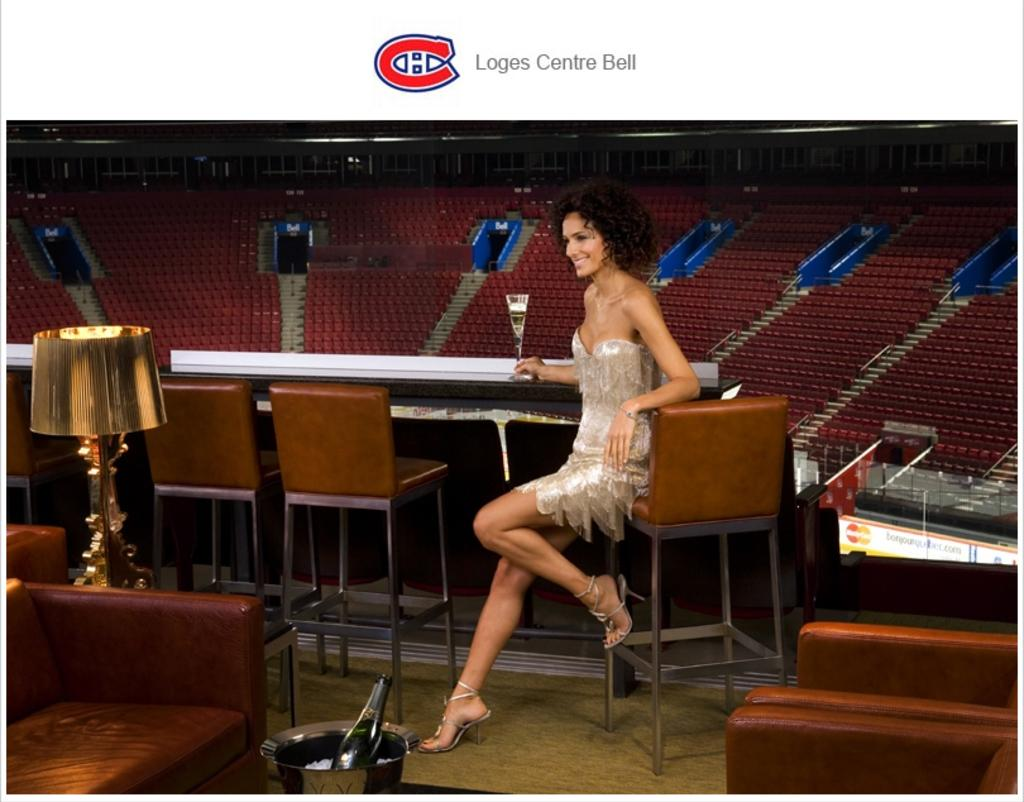Who is present in the image? There is a woman in the image. What is the woman doing in the image? The woman is sitting on a chair. What is the woman holding in the image? The woman is holding a wine glass. Where is the wine glass located in the image? The wine glass is on a table. What can be seen in the background of the image? There are chairs in the background of the image. What type of lunch is the woman eating in the image? There is no lunch visible in the image; the woman is holding a wine glass. What color is the pocket on the woman's dress in the image? The woman is not wearing a dress with a pocket in the image. 